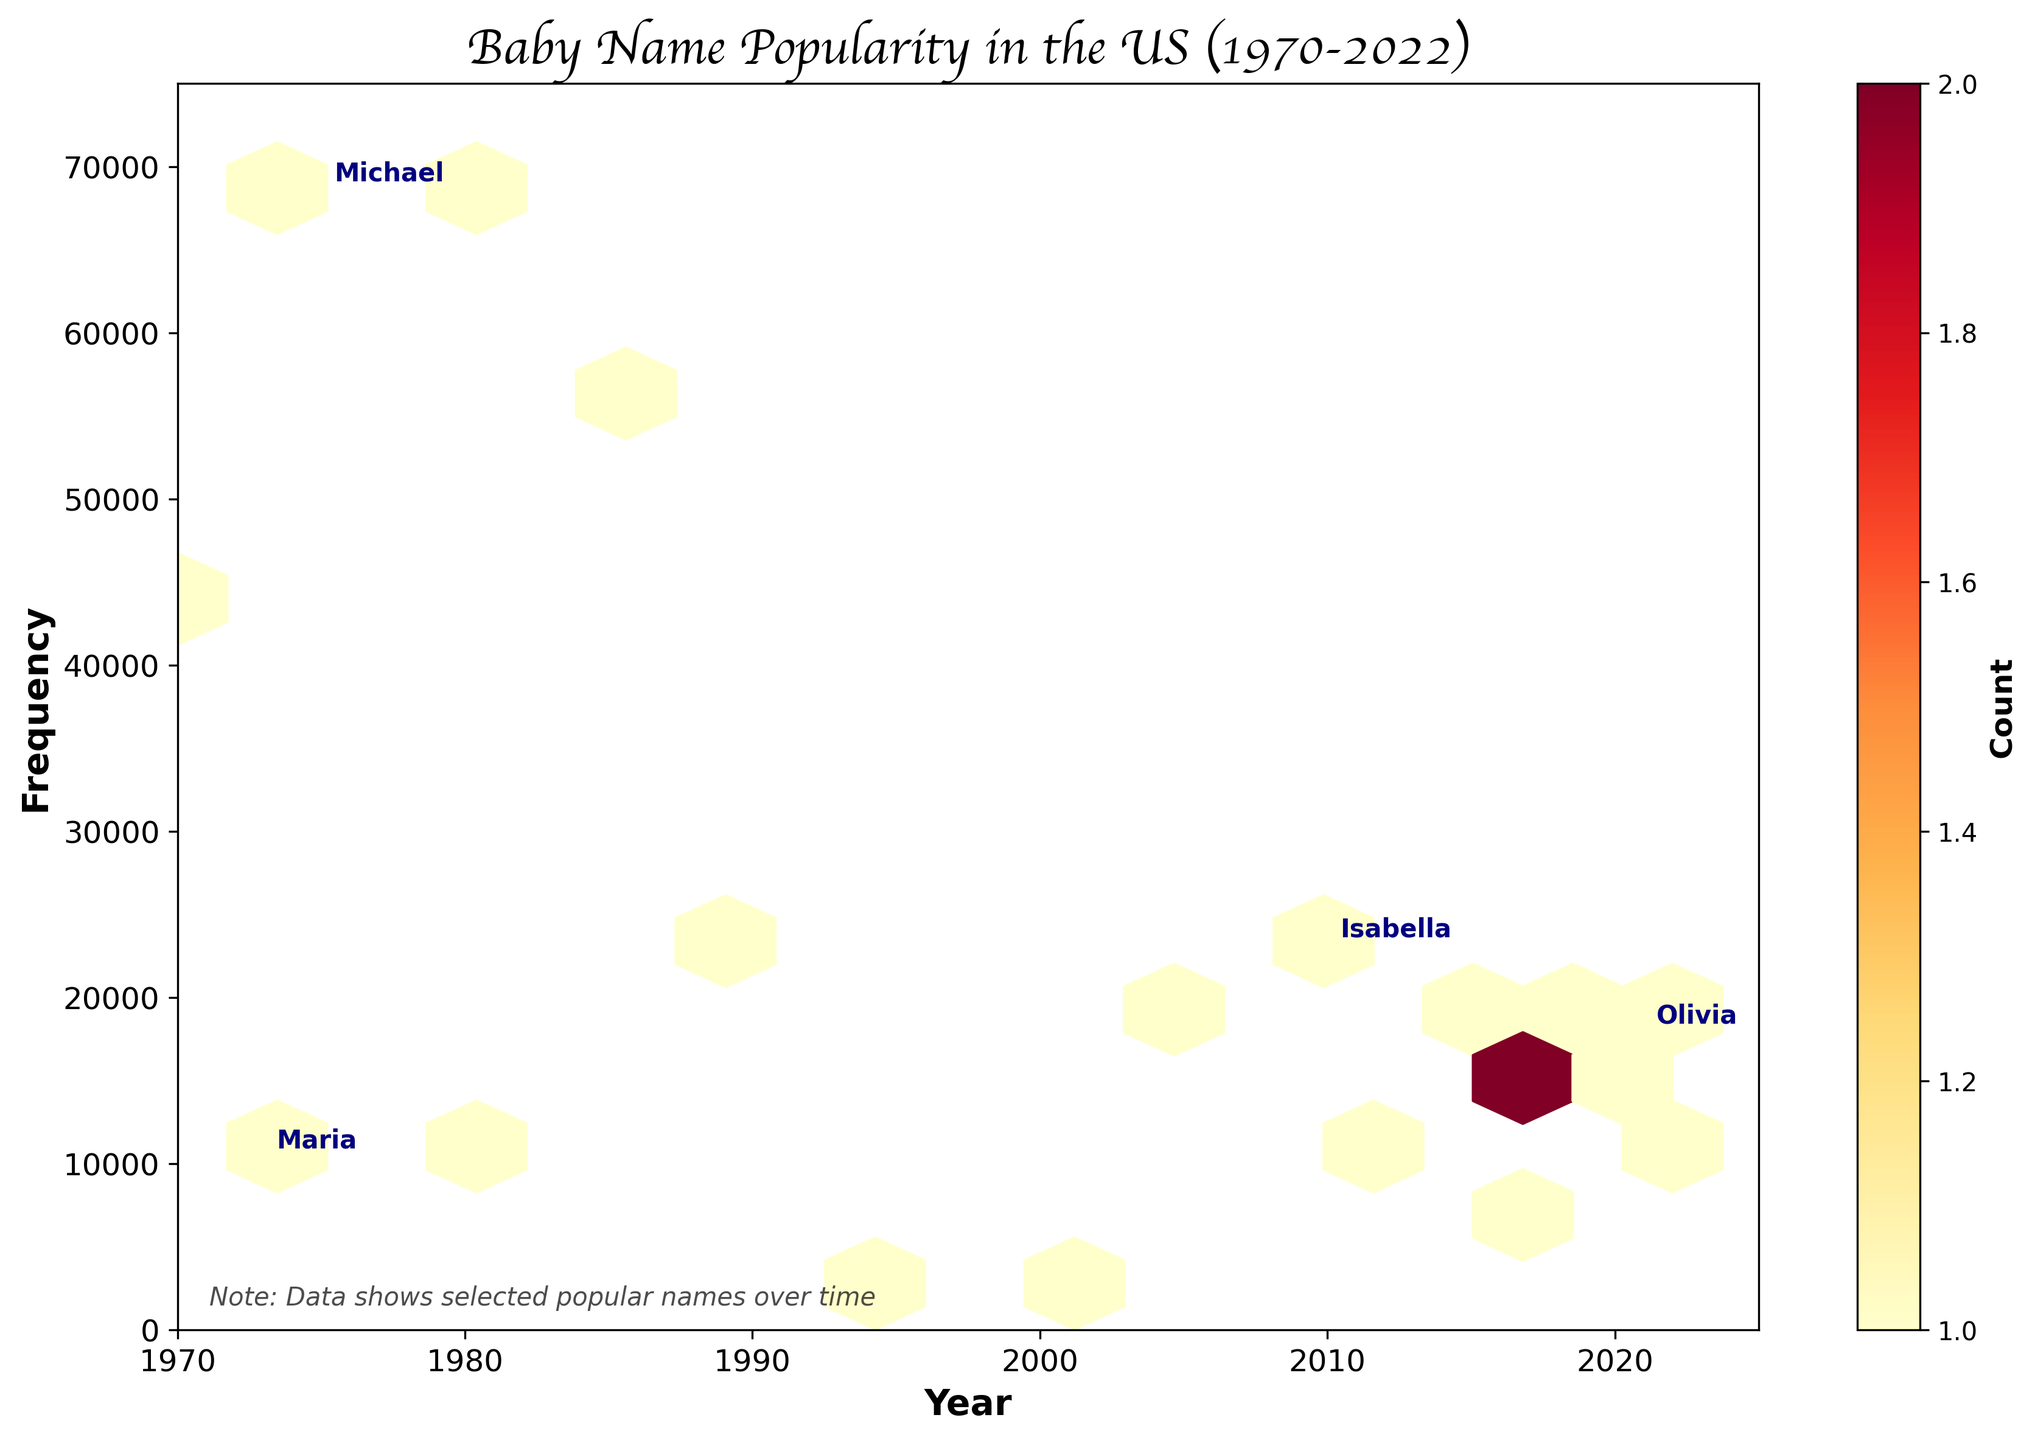why is Michael the most prominent in 1975? The hexbin plot shows frequency of baby names over the years. Michael stands out in 1975 because the frequency is high, indicating it was a very popular name that year, peaking at 68400.
Answer: It was highly popular in 1975 what is the title of the plot? The title is located at the top of the plot and describes what the plot represents. It is "Baby Name Popularity in the US (1970-2022)."
Answer: Baby Name Popularity in the US (1970-2022) how does the frequency of names change over the years? Analyzing the hexbin plot, the distribution shows that some names have rising trends, others are declining or stable. Names nearer to the bottom of the y-axis remain less frequent while high frequency names create denser hexagons.
Answer: The frequency varies; some names rise, others decline or stabilize which year shows the highest peak frequency among the names listed? Examining the y-axis, 1980's Christopher shows the peak frequency at 68700.
Answer: 1980 which names are annotated on the plot? The plot includes commentary for certain prominent names such as Maria, Isabella, Michael, and Olivia directly on the figure.
Answer: Maria, Isabella, Michael, Olivia how many names have a rising trend? Count the occurrences of 'Rising' in the data. Names such as Sofia, Diego, Liam, Noah, Emma, Mia, Camila, Sebastian, Mateo, and Olivia show a rising trend, making a total of 10.
Answer: 10 compare the popularity of Maria in 1973 to Isabella in 2010 From the hexbin plot, Maria's frequency in 1973 is 10200 while Isabella's in 2010 is at its peak of 22900, indicating Isabella was much more popular in 2010.
Answer: Isabella was more popular in 2010 why might some names show stable trends? Looking at hexagons of stable names such as Jose, Sophia, Ava, Daniel, certain cultural or generational factors might maintain their appeal consistently without sharp declines or rises. Stable peaks indicate steady popularity.
Answer: Cultural or generational factors what does the color range in the hexbin plot represent? The color gradient in the hexbin plot, ranging from light to dark, represents the count or density of data points. Darker colors show higher concentrations of popular name frequencies in specific years.
Answer: Density of data points which baby name appears to decline in frequency over time? Observing the plot, names like Maria and David show a declining trajectory over the years.
Answer: Maria, David 